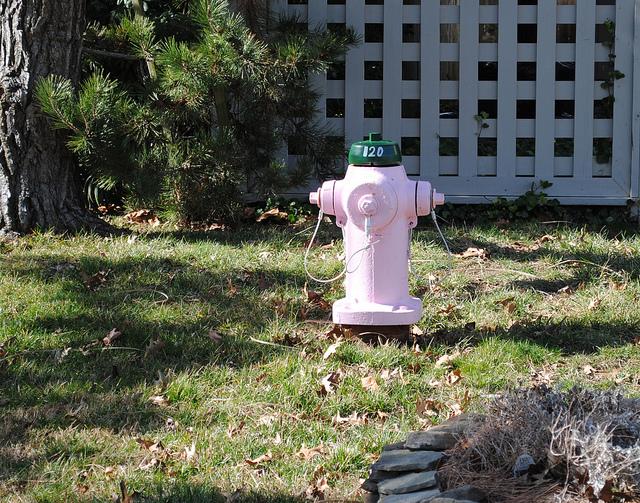What is the color of the top of the hydrant?
Quick response, please. Green. What is the color of the water pump?
Keep it brief. Pink. What material is this device made from?
Give a very brief answer. Metal. What is the color of the hydrant?
Be succinct. Pink. Where are the dry leaves?
Write a very short answer. On ground. What is the brown on the hydrant?
Short answer required. Rust. How many stories of the building can be seen?
Give a very brief answer. 0. 